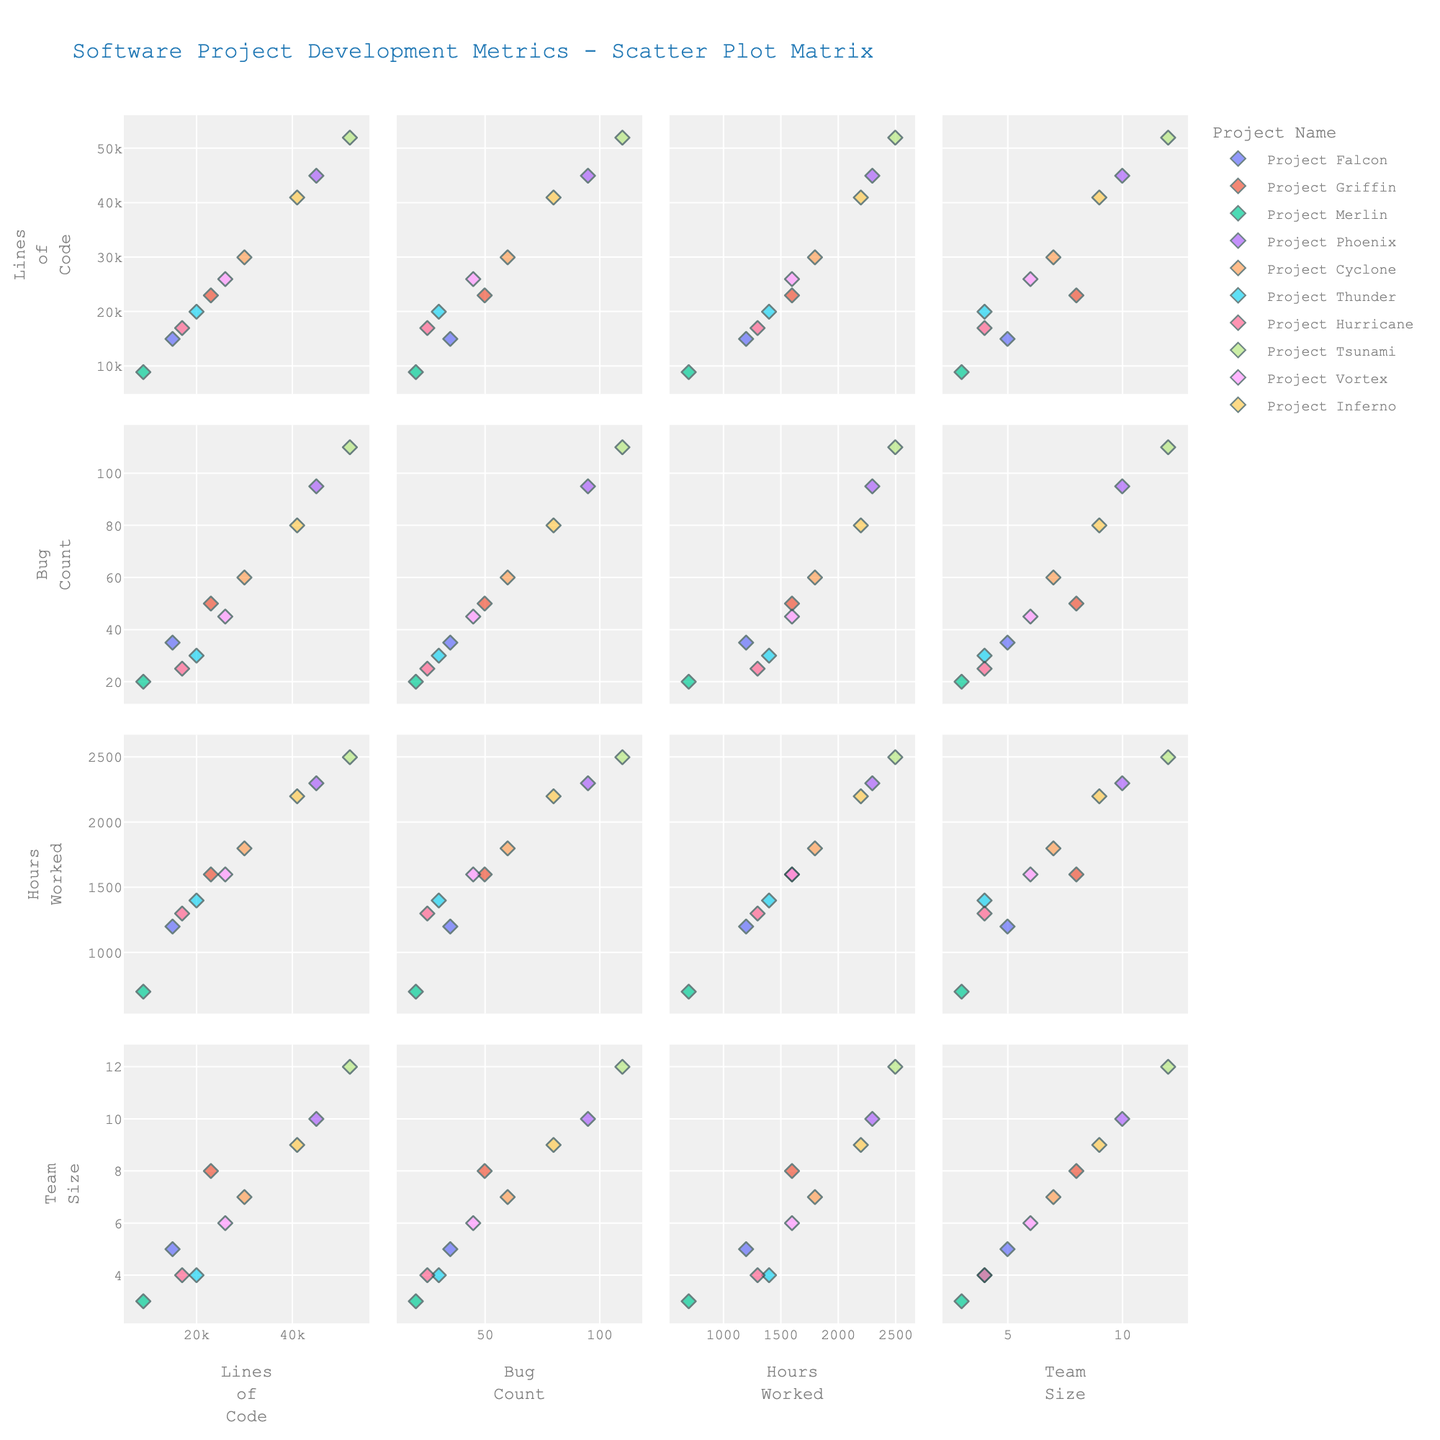What is the title of the scatter plot matrix? The title is usually displayed at the top of the plot and provides a summary of the entire figure. In this case, it reads "Software Project Development Metrics - Scatter Plot Matrix."
Answer: Software Project Development Metrics - Scatter Plot Matrix How many different project names are represented in the scatter plot matrix? Each project is distinguished by its color in the scatter plot matrix. By counting the colors or referring to the legend, we can see there are 10 projects.
Answer: 10 Which project has the highest number of "Lines of Code"? By examining the scatter plot involving the 'Lines of Code' axis, we can find the project with the highest value. Here, "Project Tsunami" stands out for having 52,000 lines of code, the highest in the dataset.
Answer: Project Tsunami In the relationship between "Bug Count" and "Hours Worked", which project shows the highest bug count? Look at the scatter plot comparing 'Bug Count' and 'Hours Worked'. The point at the highest position on the 'Bug Count' axis (110 bugs) corresponds to "Project Tsunami."
Answer: Project Tsunami Which two projects have similar "Team Size" but have a noticeable difference in their "Lines of Code"? Identify two points that align closely on the 'Team Size' axis but differ significantly on the 'Lines of Code' axis. "Project Vortex" (Team Size: 6, Lines of Code: 26,000) and "Project Cyclone" (Team Size: 7, Lines of Code: 30,000) are good examples.
Answer: Project Vortex and Project Cyclone What's the range of "Hours Worked" across all projects? Identify the minimum and maximum points on the 'Hours Worked' axis. The minimum is 700 (Project Merlin) and the maximum is 2500 (Project Tsunami), giving a range of 2500 - 700 = 1800.
Answer: 1800 Which two metrics appear to have the most direct linear relationship based on the scatter plot matrix? Observe the scatter plots to determine which pair of metrics shows the tightest clustering along a straight line. 'Lines of Code' and 'Bug Count' seem to have a strong positive linear relationship.
Answer: Lines of Code and Bug Count What is the average "Team Size" across all projects? Sum the 'Team Size' values for all projects and divide by the number of projects. Adding the sizes (5 + 8 + 3 + 10 + 7 + 4 + 4 + 12 + 6 + 9 = 68) and dividing by 10 projects, we get an average of 68/10 = 6.8.
Answer: 6.8 Which project required more than 1400 hours of work and had fewer than 40 bugs? Find points that meet both conditions on the scatter plots of 'Hours Worked' vs. 'Bug Count'. "Project Hurricane" matches both (1300 hours worked, 25 bugs) but it seems none exceed 1400 hours and fewer than 40 bugs, so none perfectly match.
Answer: None Which project has the smallest team size? By examining the 'Team Size' axis in the scatter plot, "Project Merlin" has the smallest team size with only 3 members.
Answer: Project Merlin 